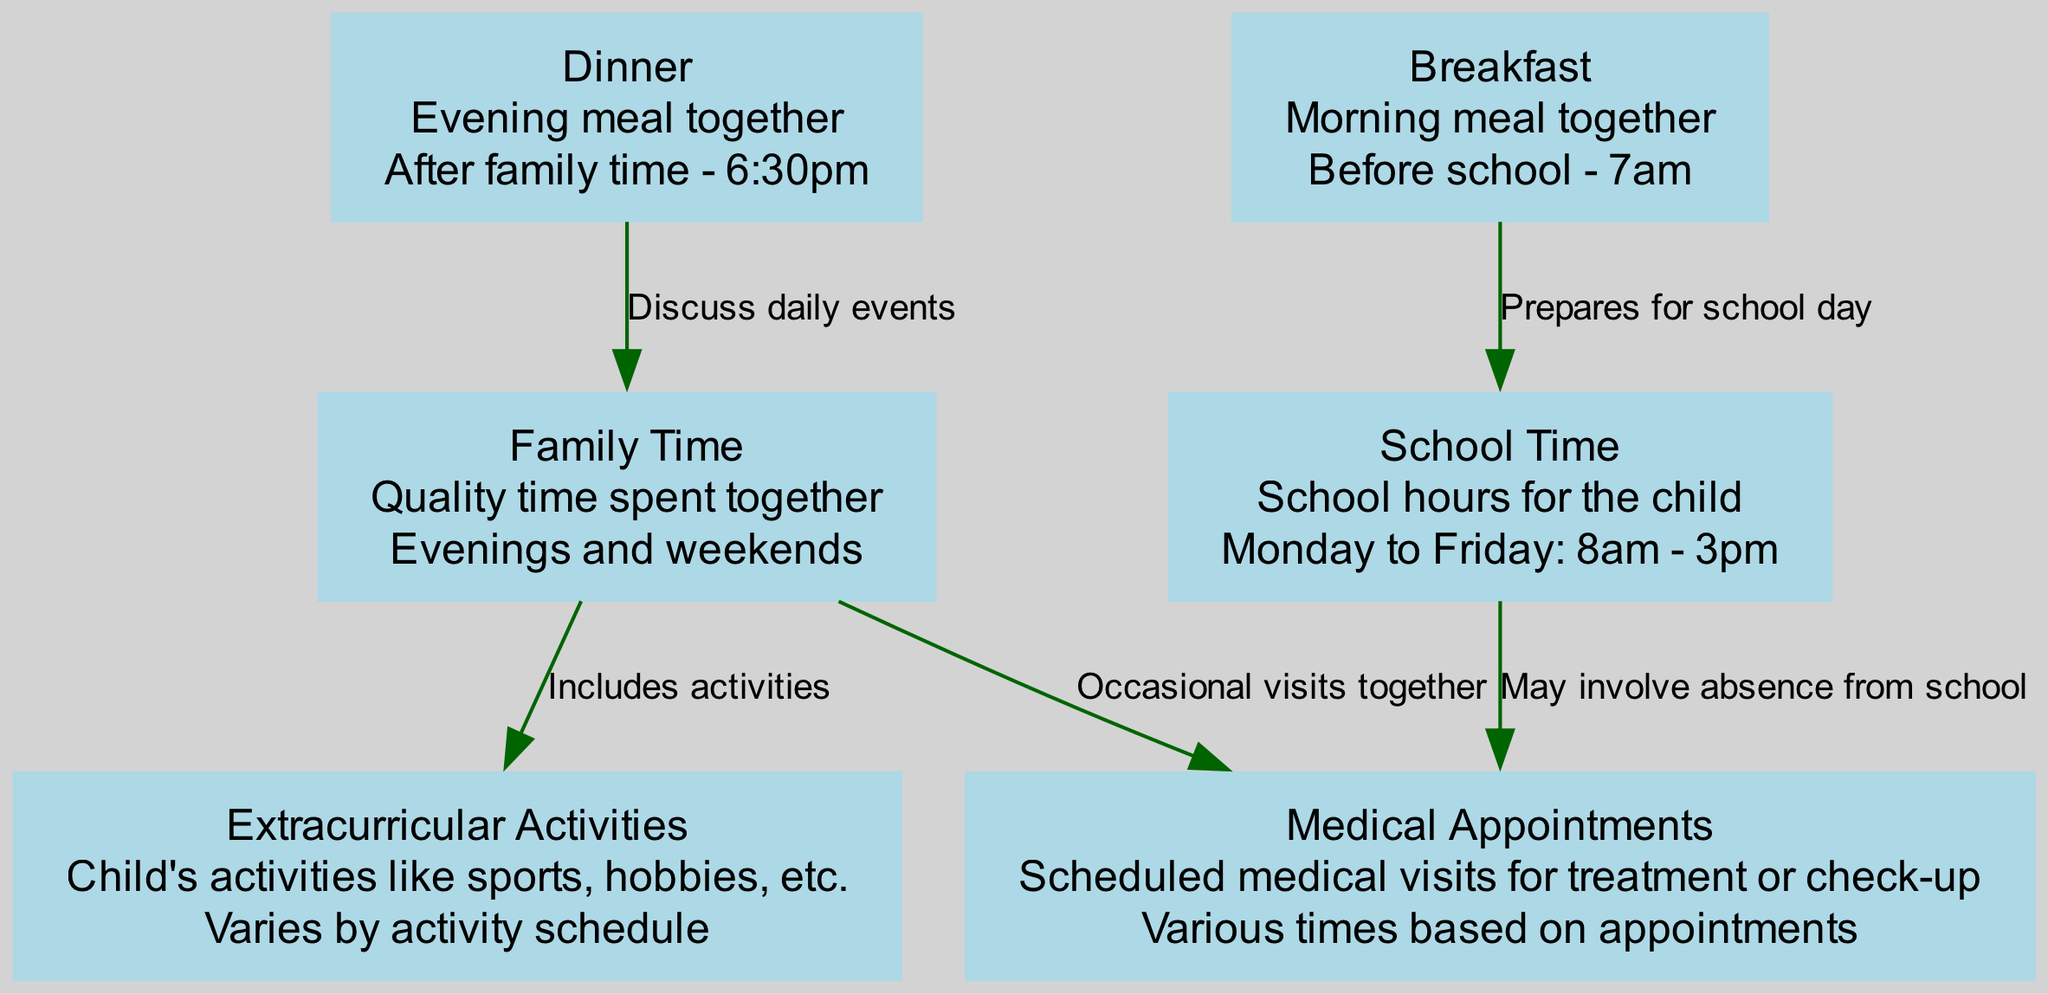What is the total number of nodes in the diagram? The diagram lists the following nodes: schoolTime, medicalAppointments, familyTime, extracurricularActivities, breakfast, and dinner. Counting these gives a total of 6 nodes.
Answer: 6 What is the purpose of the 'breakfast' node? The breakfast node is described as the morning meal together before school, specifically at 7am. This denotes its role as a part of the daily routine that prepares the child for the school day.
Answer: Morning meal together How often does school take place according to the diagram? The school time node indicates that school hours for the child are from 8am to 3pm, Monday to Friday. This specifies that school occurs 5 days a week.
Answer: 5 days a week What is the relationship between 'familyTime' and 'extracurricularActivities'? The diagram states that family time includes activities, signifying that extracurricular activities are part of the quality time spent together by the family.
Answer: Includes activities How many edges connect to the 'medicalAppointments' node? The diagram indicates that the medicalAppointments node is connected by three edges: one from schoolTime (may involve absence from school), one from familyTime (occasional visits together), and the other from extracurricularActivities (not directly noted in the diagram). This shows a total of 2 connections specifically mentioned.
Answer: 2 connections Which daily meal follows family time in the schedule? The diagram indicates that dinner comes after family time, specifically noted at 6:30pm as the time for the evening meal together.
Answer: Dinner How might attending medical appointments affect school? According to the diagram, there is a direct connection from schoolTime to medicalAppointments stating it may involve absence from school, indicating scheduling conflicts can lead to missed school days.
Answer: May involve absence from school What time does the child typically get ready for school? The diagram indicates that breakfast is eaten before school at 7am, which implies this is the time set for preparing the child for the school day.
Answer: 7am What does the 'dinner' node facilitate for the family? The diagram connects the dinner node to familyTime, indicating that dinner serves as a time for the family to discuss daily events together, enhancing their communication and bonding.
Answer: Discuss daily events 